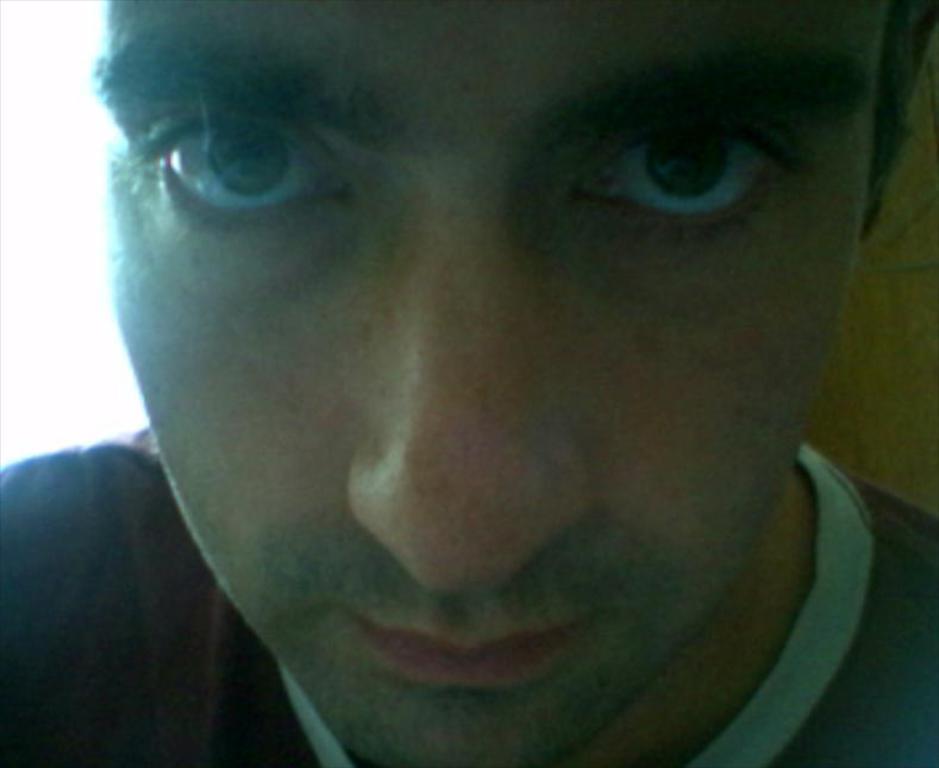Can you describe this image briefly? In this picture, we see a man in black T-shirt. We can see the eyes, nose and mouth of the man. Behind him, we see a wall. On the left side, it is white in color. 